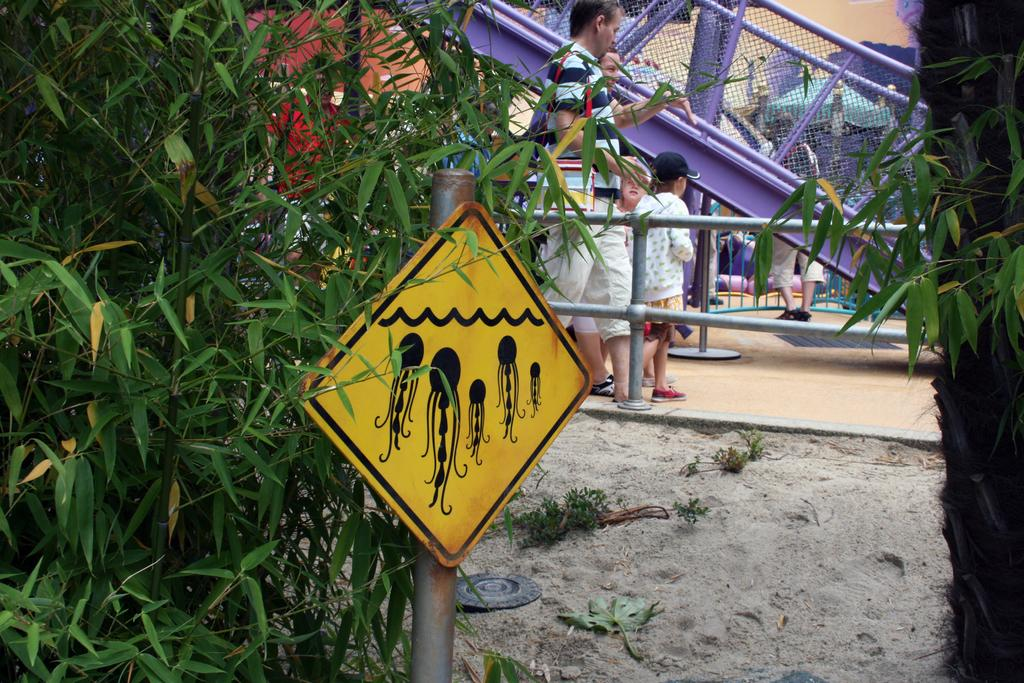What are the people in the image doing? The people in the image are standing on the ground. What can be seen on the left side of the image? There is a yellow color sign board and trees on the left side of the image. What is visible in the background of the image? There is a fence and other objects visible in the background of the image. What type of thread is being used by the achiever in the image? There is no achiever or thread present in the image. 